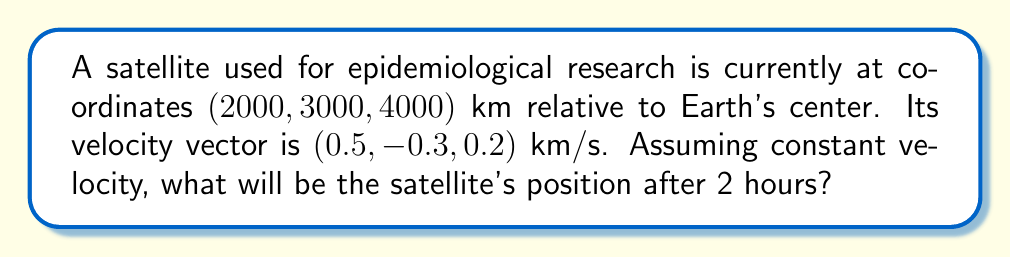What is the answer to this math problem? To solve this problem, we'll use the linear motion equation:

$$\text{Final Position} = \text{Initial Position} + \text{Velocity} \times \text{Time}$$

Let's break it down step-by-step:

1) Convert time to seconds:
   2 hours = 2 × 3600 = 7200 seconds

2) Calculate the displacement in each direction:
   x-displacement: $0.5 \text{ km/s} \times 7200 \text{ s} = 3600 \text{ km}$
   y-displacement: $-0.3 \text{ km/s} \times 7200 \text{ s} = -2160 \text{ km}$
   z-displacement: $0.2 \text{ km/s} \times 7200 \text{ s} = 1440 \text{ km}$

3) Add the displacement to the initial position:
   x-coordinate: $2000 \text{ km} + 3600 \text{ km} = 5600 \text{ km}$
   y-coordinate: $3000 \text{ km} + (-2160 \text{ km}) = 840 \text{ km}$
   z-coordinate: $4000 \text{ km} + 1440 \text{ km} = 5440 \text{ km}$

Therefore, the final position of the satellite after 2 hours will be $(5600, 840, 5440)$ km.
Answer: $(5600, 840, 5440)$ km 